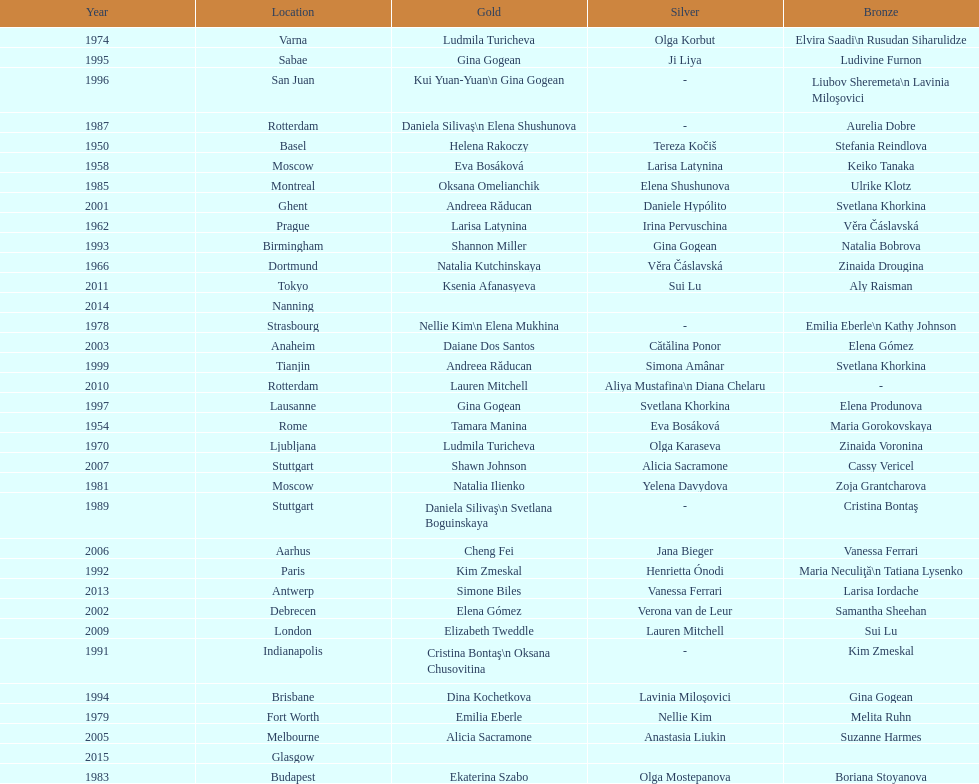How many consecutive floor exercise gold medals did romanian star andreea raducan win at the world championships? 2. 